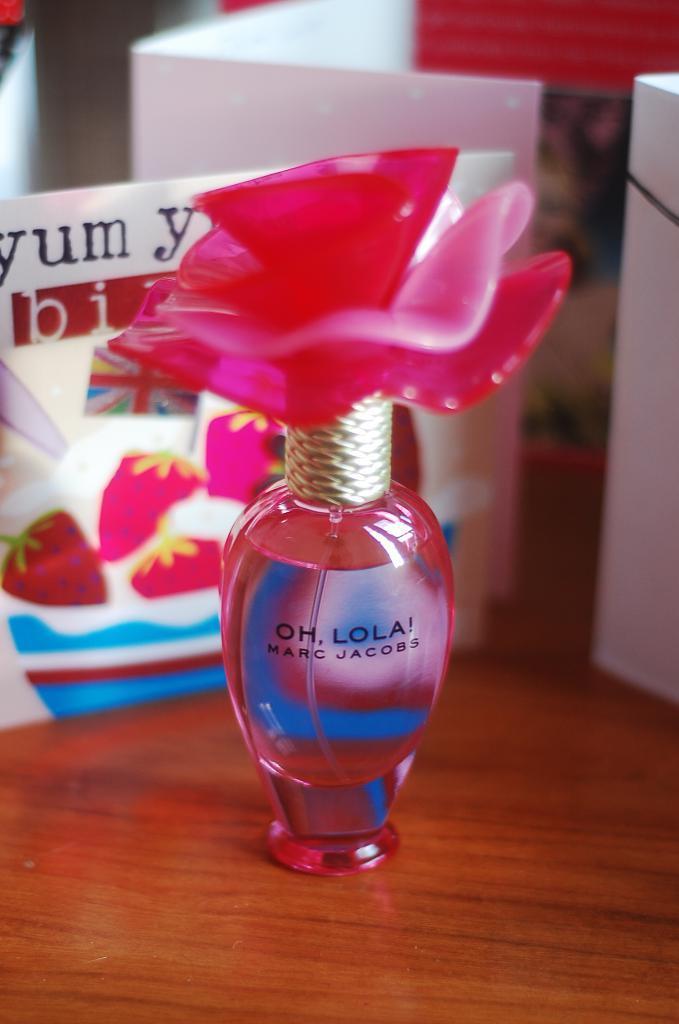<image>
Describe the image concisely. A bottle of Marc Jacobs perfume is pink in color. 